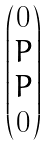<formula> <loc_0><loc_0><loc_500><loc_500>\begin{pmatrix} 0 \\ P \\ P \\ 0 \end{pmatrix}</formula> 